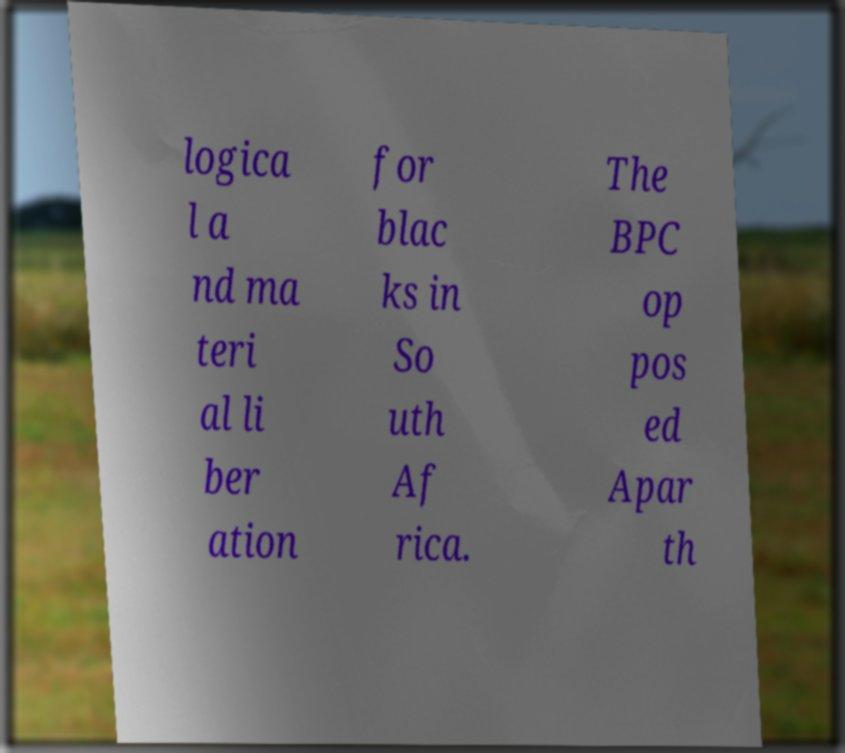There's text embedded in this image that I need extracted. Can you transcribe it verbatim? logica l a nd ma teri al li ber ation for blac ks in So uth Af rica. The BPC op pos ed Apar th 